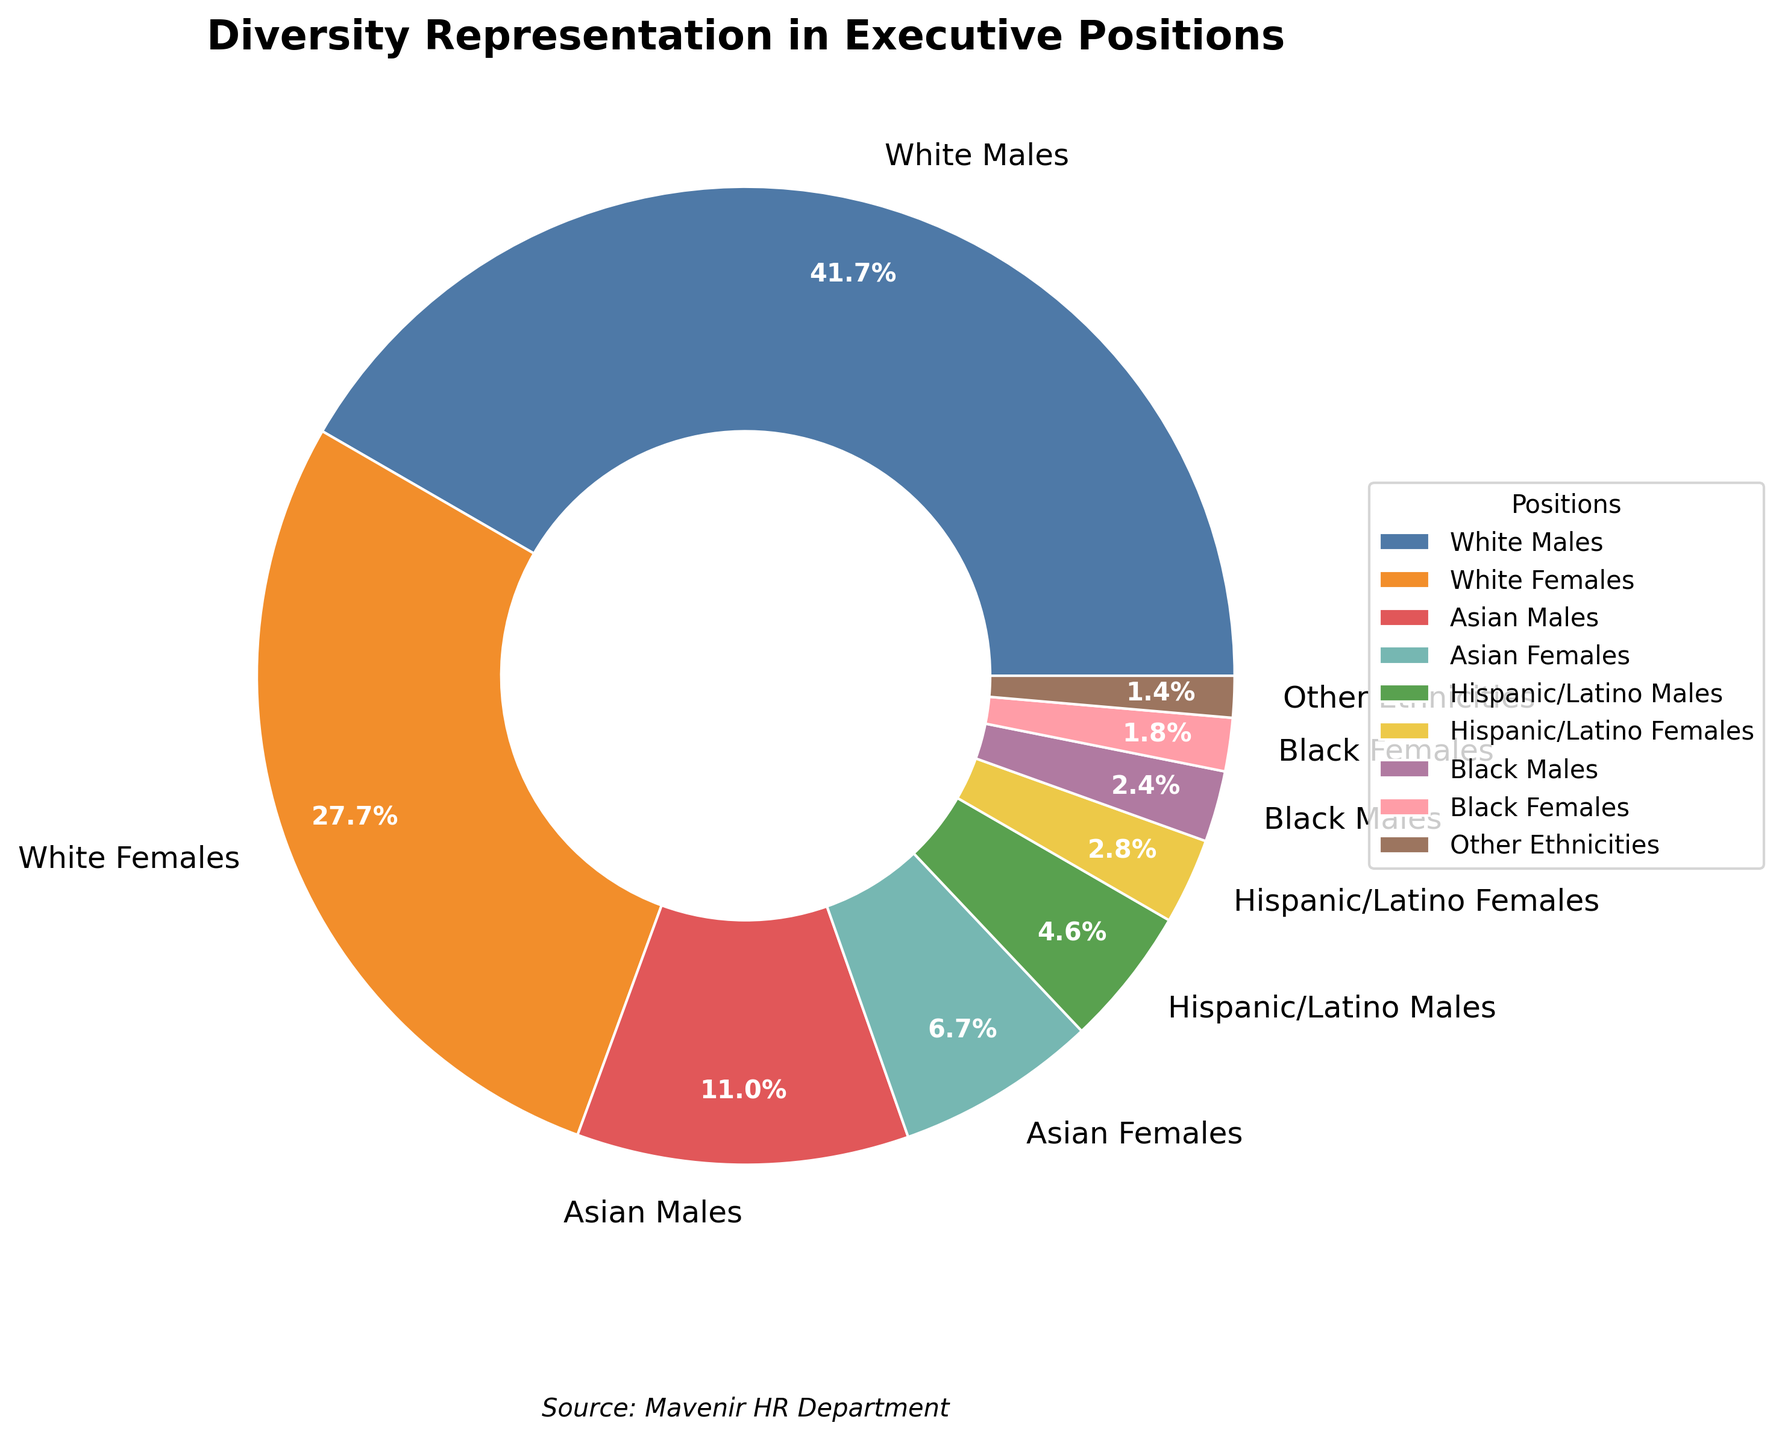What is the combined percentage of White Males and White Females in executive positions? Add the percentages for White Males and White Females: 42.5% + 28.3% = 70.8%
Answer: 70.8% Which ethnic group has the lowest representation in executive positions? According to the chart, Black Females have the lowest representation at 1.8%
Answer: Black Females Which group has a higher percentage, Asian Males or Hispanic/Latino Males? Compare the percentages for Asian Males (11.2%) and Hispanic/Latino Males (4.7%). Asian Males have a higher percentage
Answer: Asian Males How much higher is the representation of White Males compared to Asian Females? Subtract the percentage of Asian Females from White Males: 42.5% - 6.8% = 35.7%
Answer: 35.7% What is the percentage difference between Hispanic/Latino Females and Black Males representation? Subtract the percentage of Black Males from Hispanic/Latino Females: 2.9% - 2.4% = 0.5%
Answer: 0.5% What is the combined percentage of all female groups in executive positions? Add the percentages of all female groups: White Females (28.3%) + Asian Females (6.8%) + Hispanic/Latino Females (2.9%) + Black Females (1.8%) = 39.8%
Answer: 39.8% Which group has a larger percentage, Asian Females or Black Males? Compare the percentages for Asian Females (6.8%) and Black Males (2.4%). Asian Females have a larger percentage
Answer: Asian Females Approximately what fraction of the pie chart is represented by White Males? White Males represent 42.5% which is approximately 2/5 of the pie chart
Answer: 2/5 What is the second most represented group in executive positions? The second highest percentage after White Males (42.5%) is White Females with 28.3%
Answer: White Females Which groups combined make up less than 10% of the pie chart? Add the percentages of groups with less than 10% representation: Hispanic/Latino Females (2.9%) + Black Males (2.4%) + Black Females (1.8%) + Other Ethnicities (1.4%) = 8.5%
Answer: Hispanic/Latino Females, Black Males, Black Females, Other Ethnicities 